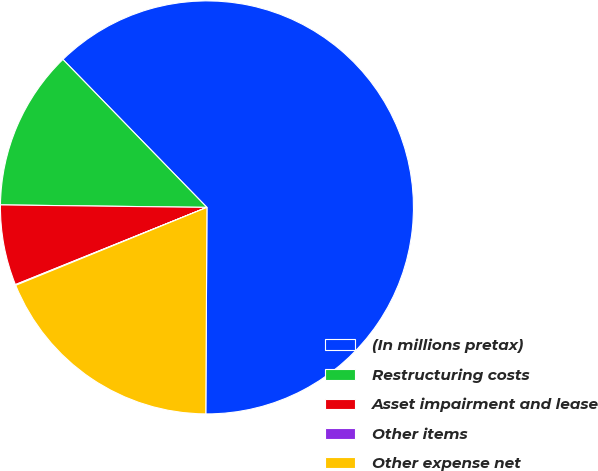Convert chart to OTSL. <chart><loc_0><loc_0><loc_500><loc_500><pie_chart><fcel>(In millions pretax)<fcel>Restructuring costs<fcel>Asset impairment and lease<fcel>Other items<fcel>Other expense net<nl><fcel>62.37%<fcel>12.52%<fcel>6.29%<fcel>0.06%<fcel>18.75%<nl></chart> 